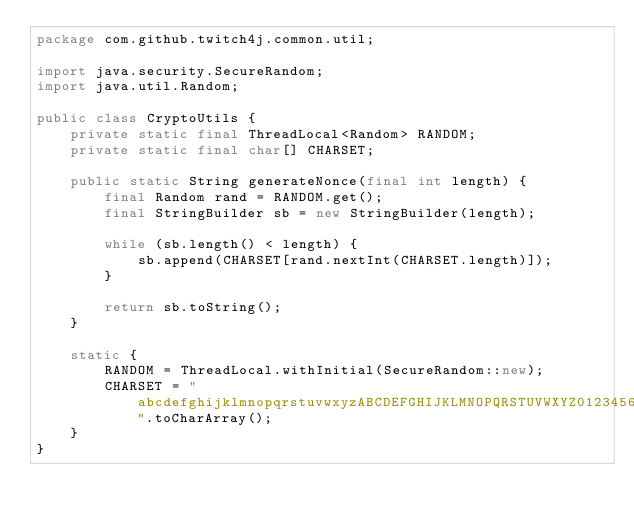Convert code to text. <code><loc_0><loc_0><loc_500><loc_500><_Java_>package com.github.twitch4j.common.util;

import java.security.SecureRandom;
import java.util.Random;

public class CryptoUtils {
    private static final ThreadLocal<Random> RANDOM;
    private static final char[] CHARSET;

    public static String generateNonce(final int length) {
        final Random rand = RANDOM.get();
        final StringBuilder sb = new StringBuilder(length);

        while (sb.length() < length) {
            sb.append(CHARSET[rand.nextInt(CHARSET.length)]);
        }

        return sb.toString();
    }

    static {
        RANDOM = ThreadLocal.withInitial(SecureRandom::new);
        CHARSET = "abcdefghijklmnopqrstuvwxyzABCDEFGHIJKLMNOPQRSTUVWXYZ0123456789".toCharArray();
    }
}
</code> 